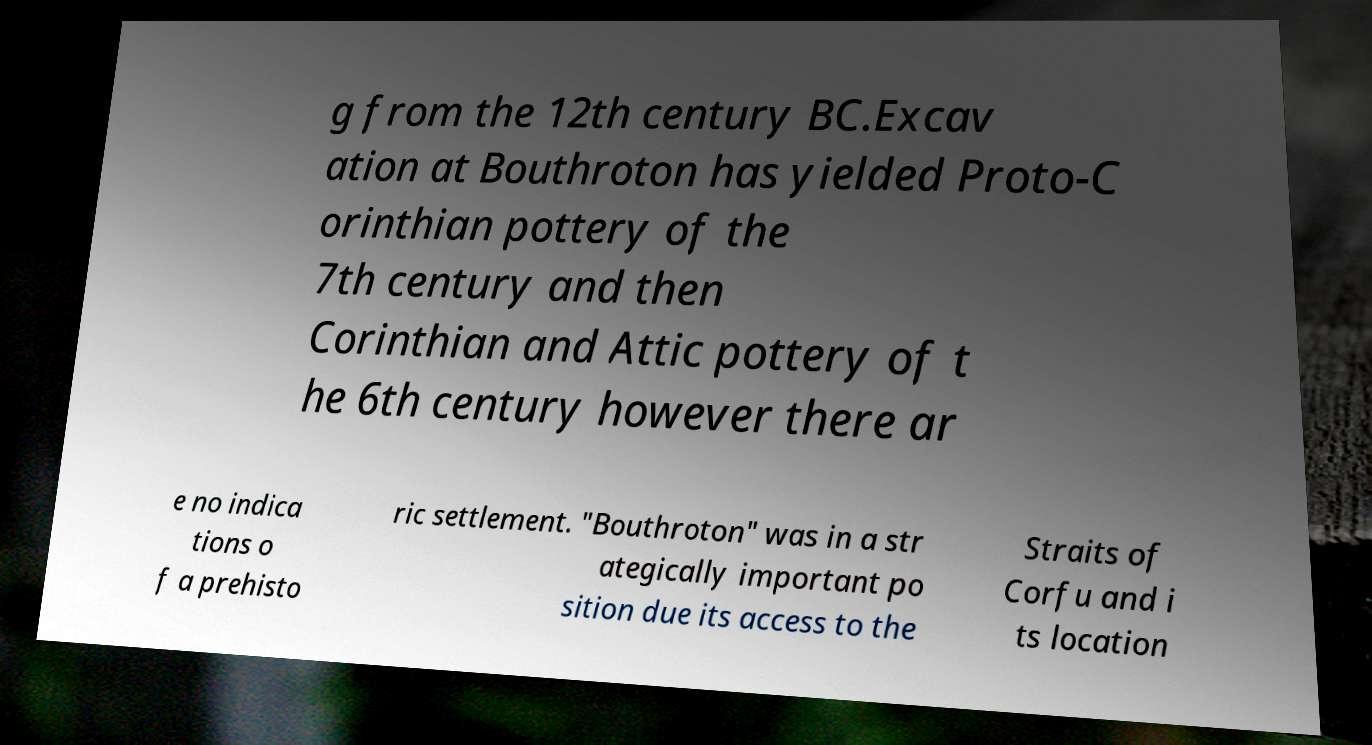Can you read and provide the text displayed in the image?This photo seems to have some interesting text. Can you extract and type it out for me? g from the 12th century BC.Excav ation at Bouthroton has yielded Proto-C orinthian pottery of the 7th century and then Corinthian and Attic pottery of t he 6th century however there ar e no indica tions o f a prehisto ric settlement. "Bouthroton" was in a str ategically important po sition due its access to the Straits of Corfu and i ts location 